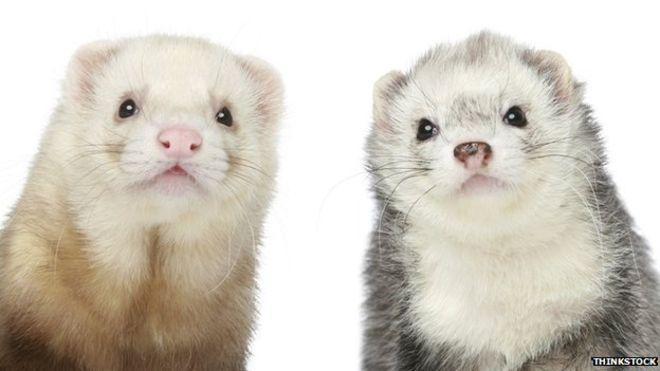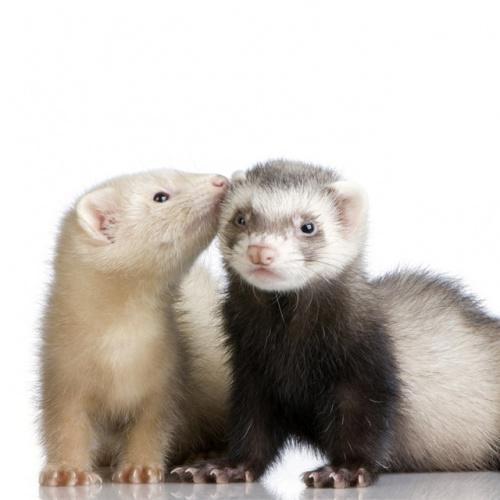The first image is the image on the left, the second image is the image on the right. Evaluate the accuracy of this statement regarding the images: "a pair of ferrets are next to each other on top of draped fabric". Is it true? Answer yes or no. No. 